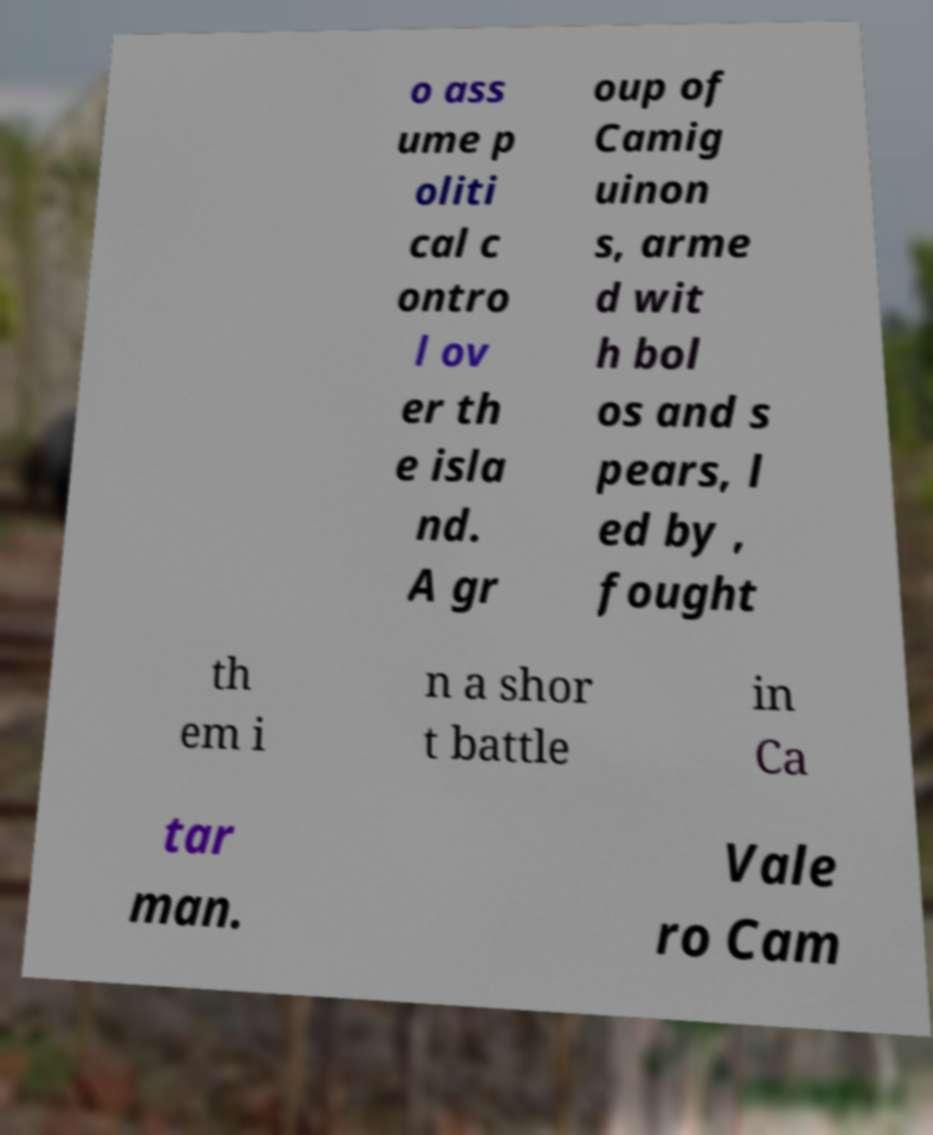Can you read and provide the text displayed in the image?This photo seems to have some interesting text. Can you extract and type it out for me? o ass ume p oliti cal c ontro l ov er th e isla nd. A gr oup of Camig uinon s, arme d wit h bol os and s pears, l ed by , fought th em i n a shor t battle in Ca tar man. Vale ro Cam 